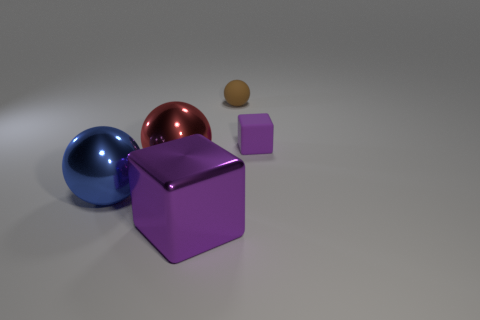How many green objects are either rubber spheres or big objects?
Provide a succinct answer. 0. There is a red shiny sphere; does it have the same size as the purple cube that is on the right side of the brown rubber ball?
Provide a succinct answer. No. What is the material of the other small thing that is the same shape as the blue shiny thing?
Keep it short and to the point. Rubber. How many other objects are there of the same size as the matte cube?
Provide a succinct answer. 1. What shape is the purple thing that is on the right side of the cube on the left side of the object that is behind the tiny purple rubber block?
Provide a succinct answer. Cube. The thing that is both on the right side of the red ball and in front of the large red shiny sphere has what shape?
Your response must be concise. Cube. How many objects are either large red metallic balls or red balls in front of the small sphere?
Offer a very short reply. 1. Do the small purple cube and the brown sphere have the same material?
Your answer should be very brief. Yes. What number of other objects are the same shape as the blue shiny object?
Make the answer very short. 2. There is a object that is both to the left of the tiny purple cube and to the right of the big purple block; what is its size?
Your response must be concise. Small. 